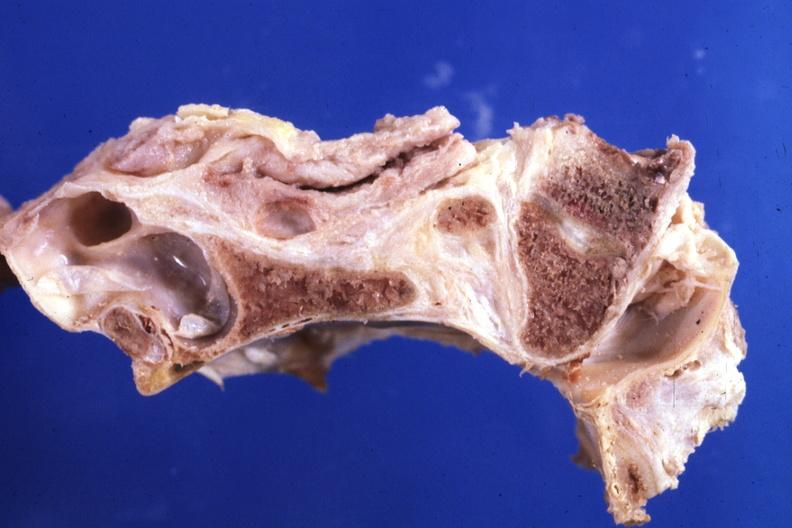s embryo-fetus present?
Answer the question using a single word or phrase. No 